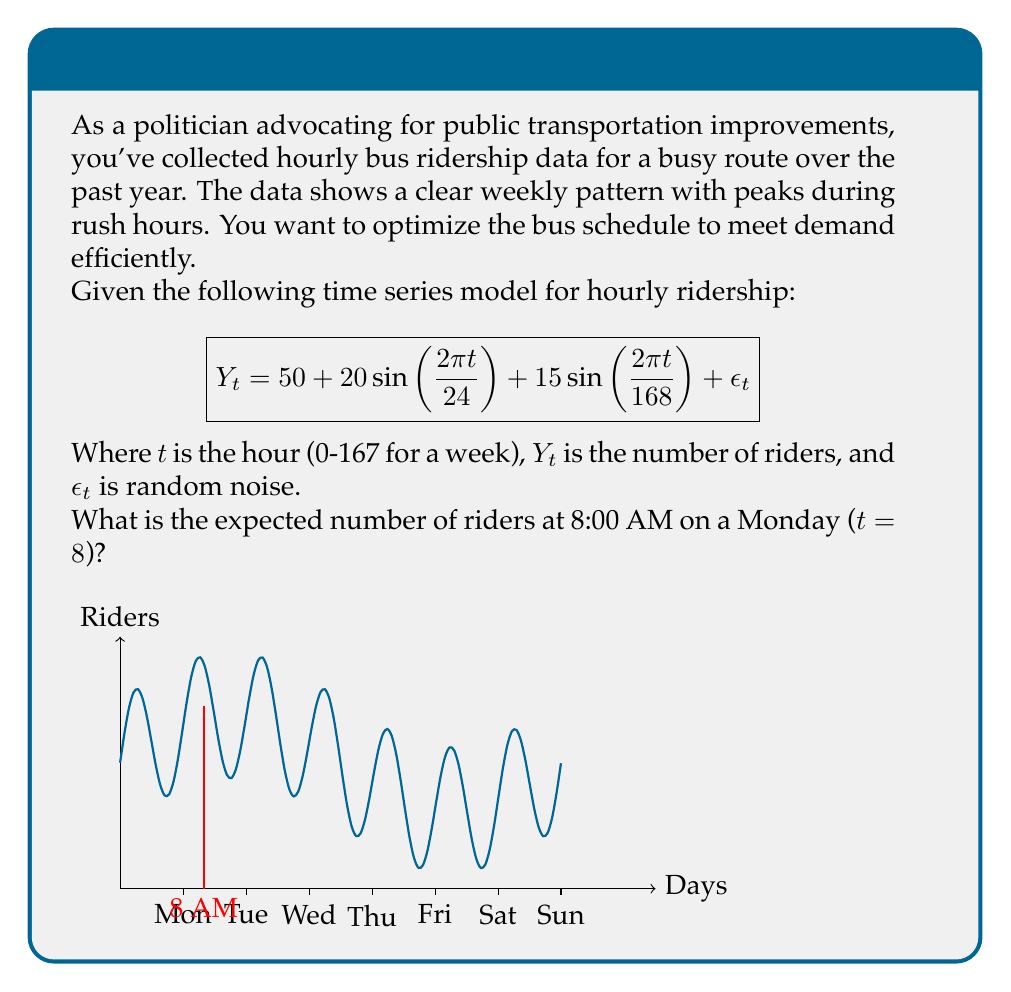Teach me how to tackle this problem. To solve this problem, we need to evaluate the given time series model at t = 8 (8:00 AM on Monday). Let's break it down step-by-step:

1) The model is: $Y_t = 50 + 20\sin(\frac{2\pi t}{24}) + 15\sin(\frac{2\pi t}{168}) + \epsilon_t$

2) We're interested in the expected number of riders, so we can ignore the random noise term $\epsilon_t$.

3) Substitute t = 8:

   $Y_8 = 50 + 20\sin(\frac{2\pi \cdot 8}{24}) + 15\sin(\frac{2\pi \cdot 8}{168})$

4) Simplify the arguments of the sine functions:
   
   $Y_8 = 50 + 20\sin(\frac{2\pi}{3}) + 15\sin(\frac{\pi}{21})$

5) Calculate the sine values:
   $\sin(\frac{2\pi}{3}) \approx 0.866$
   $\sin(\frac{\pi}{21}) \approx 0.149$

6) Multiply and sum:
   $Y_8 = 50 + (20 \cdot 0.866) + (15 \cdot 0.149)$
   $Y_8 = 50 + 17.32 + 2.235$
   $Y_8 = 69.555$

7) Round to the nearest whole number, as we can't have a fraction of a person:
   $Y_8 \approx 70$

Therefore, the expected number of riders at 8:00 AM on a Monday is approximately 70.
Answer: 70 riders 